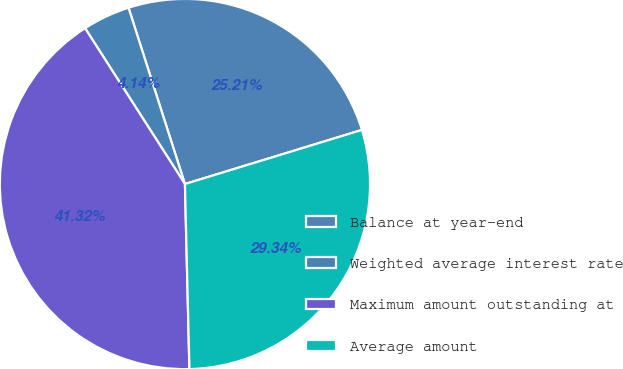Convert chart. <chart><loc_0><loc_0><loc_500><loc_500><pie_chart><fcel>Balance at year-end<fcel>Weighted average interest rate<fcel>Maximum amount outstanding at<fcel>Average amount<nl><fcel>25.21%<fcel>4.14%<fcel>41.32%<fcel>29.34%<nl></chart> 